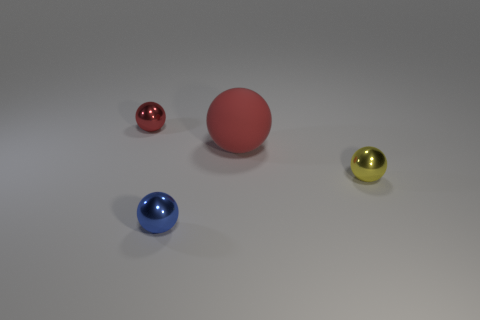Is the number of large matte objects that are on the left side of the blue shiny sphere the same as the number of tiny cyan metal cylinders?
Your answer should be compact. Yes. There is a red ball in front of the small red ball; are there any tiny spheres on the right side of it?
Keep it short and to the point. Yes. How many other things are the same color as the rubber ball?
Ensure brevity in your answer.  1. The large sphere is what color?
Keep it short and to the point. Red. What is the size of the thing that is both to the left of the rubber sphere and in front of the large sphere?
Ensure brevity in your answer.  Small. How many objects are either tiny shiny balls that are in front of the tiny yellow ball or small yellow objects?
Offer a very short reply. 2. What is the shape of the small blue object that is the same material as the small red object?
Your answer should be compact. Sphere. What shape is the small blue thing?
Your answer should be very brief. Sphere. What is the color of the object that is both to the left of the tiny yellow metallic object and in front of the rubber object?
Keep it short and to the point. Blue. There is a yellow metal thing that is the same size as the blue ball; what is its shape?
Offer a terse response. Sphere. 